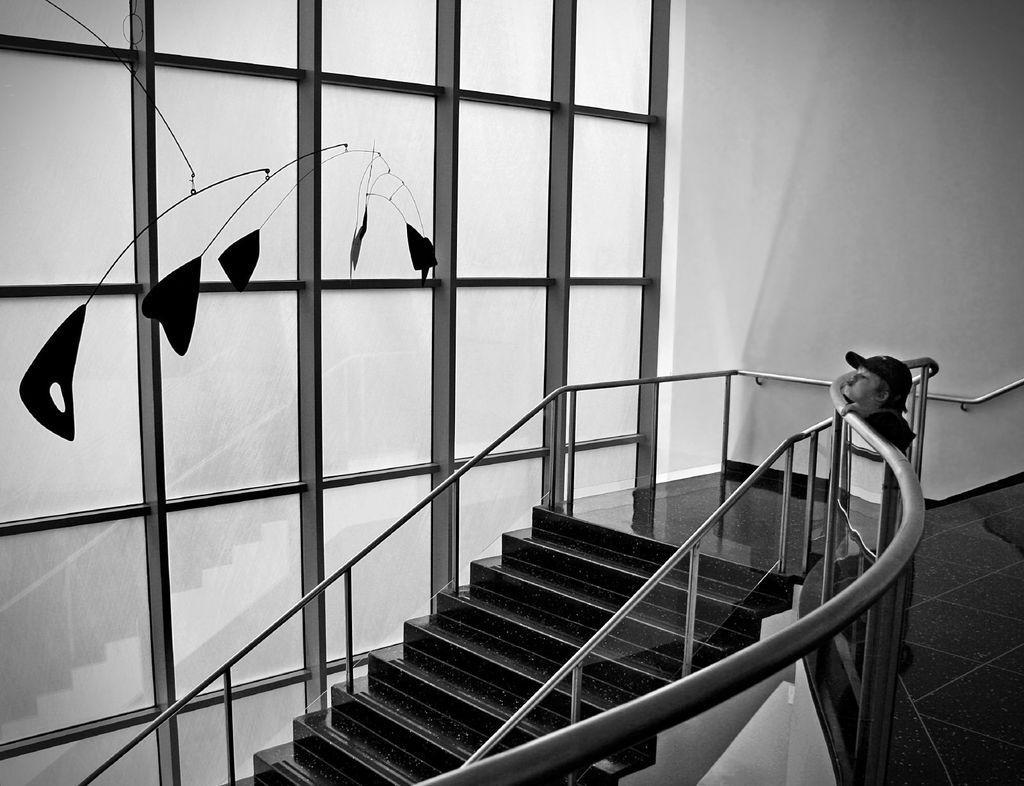Please provide a concise description of this image. This is a black and white image. In the center of the image there is a staircase. There is a staircase railing. There is a boy at the right side of the image wearing a cap. At the background of the image there is a wall. 